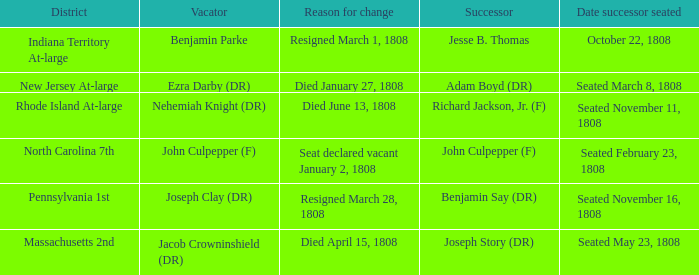How many vacators have October 22, 1808 as date successor seated? 1.0. 